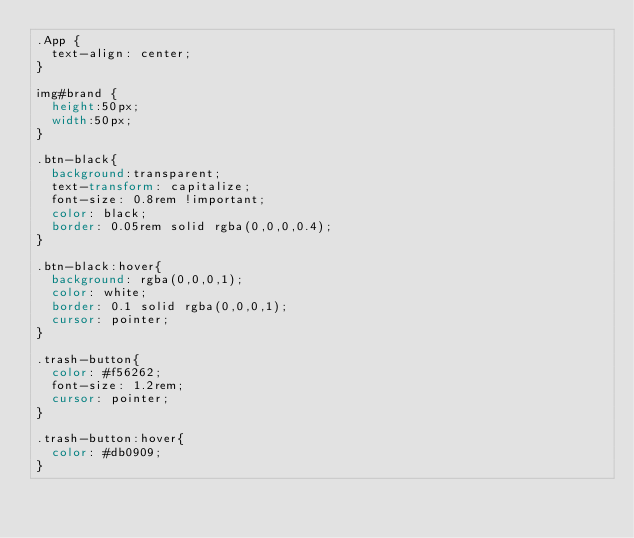<code> <loc_0><loc_0><loc_500><loc_500><_CSS_>.App {
  text-align: center;
}

img#brand {
  height:50px;
  width:50px;
}

.btn-black{
  background:transparent;
  text-transform: capitalize;
  font-size: 0.8rem !important;
  color: black;
  border: 0.05rem solid rgba(0,0,0,0.4);
}

.btn-black:hover{
  background: rgba(0,0,0,1);
  color: white;
  border: 0.1 solid rgba(0,0,0,1);
  cursor: pointer;
}

.trash-button{
  color: #f56262;
  font-size: 1.2rem;
  cursor: pointer;
}

.trash-button:hover{
  color: #db0909;
}
</code> 